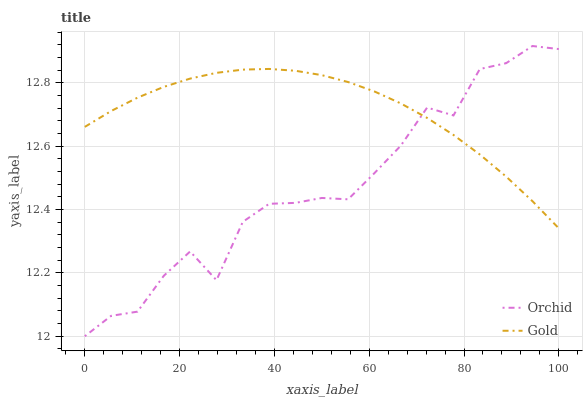Does Orchid have the minimum area under the curve?
Answer yes or no. Yes. Does Gold have the maximum area under the curve?
Answer yes or no. Yes. Does Orchid have the maximum area under the curve?
Answer yes or no. No. Is Gold the smoothest?
Answer yes or no. Yes. Is Orchid the roughest?
Answer yes or no. Yes. Is Orchid the smoothest?
Answer yes or no. No. Does Orchid have the lowest value?
Answer yes or no. Yes. Does Orchid have the highest value?
Answer yes or no. Yes. Does Orchid intersect Gold?
Answer yes or no. Yes. Is Orchid less than Gold?
Answer yes or no. No. Is Orchid greater than Gold?
Answer yes or no. No. 